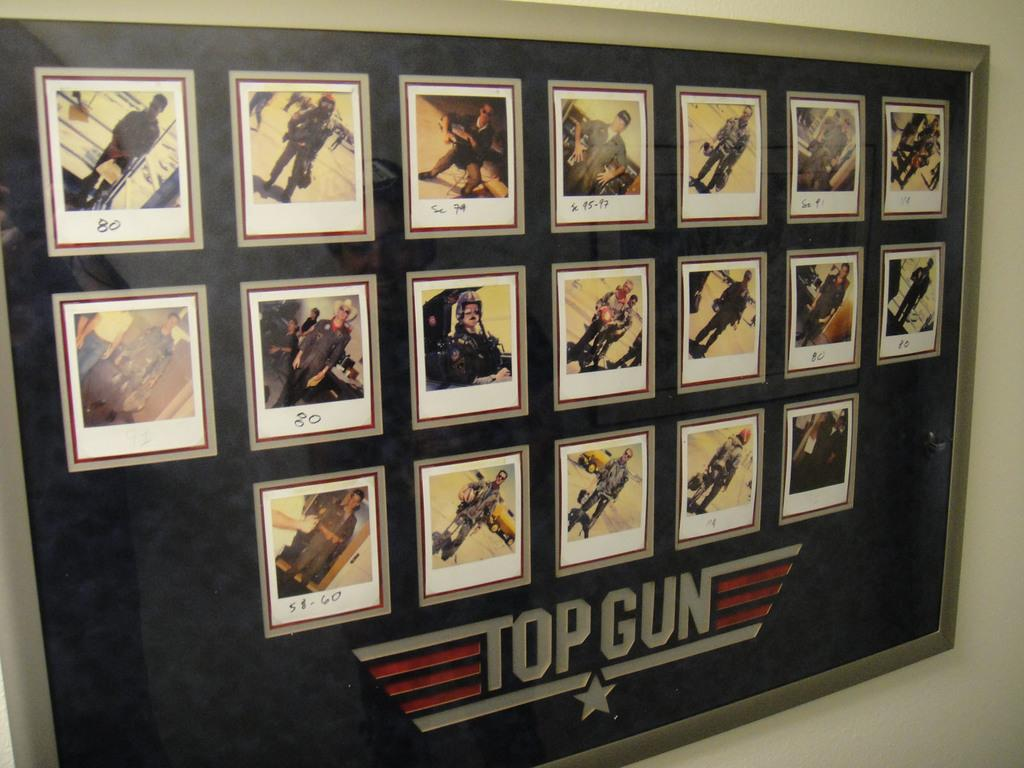<image>
Share a concise interpretation of the image provided. Display of many photos and the word TOP GUN on the bottom. 